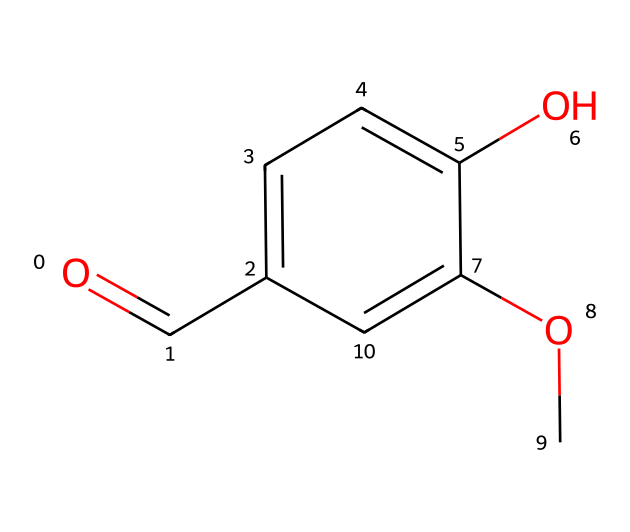What is the molecular formula of vanillin? To derive the molecular formula from the SMILES representation, count the carbon (C), hydrogen (H), and oxygen (O) atoms. The structure has 8 carbons, 8 hydrogens, and 3 oxygens, leading to a formula of C8H8O3.
Answer: C8H8O3 How many hydroxyl (–OH) groups are present in vanillin? Looking at the SMILES structure, the presence of an –OH group is indicated by the "O" connected to a carbon "c". There is one such –OH group in the structure.
Answer: 1 What functional groups are present in vanillin? Analyzing the structure, vanillin features a hydroxyl group (–OH) and an aldehyde group (–CHO) due to the presence of the carbonyl oxygen (=O) next to a carbon atom.
Answer: hydroxyl, aldehyde Is vanillin aromatic? The presence of an aromatic ring is evident from the "c" notations in the SMILES, indicating that carbon atoms are part of a cyclic, delocalized electron system. This confirms the aromatic nature of the compound.
Answer: yes What type of compound is vanillin classified as? Since vanillin contains a phenolic hydroxyl group and an aldehyde group, it fits the definition of a phenolic compound, specifically a phenolic aldehyde.
Answer: phenolic aldehyde How many double bonds are present in vanillin? Evaluating the structure, there is one double bond in the carbonyl group (=O) and three double bonds implicit in the aromatic ring connections, leading to a total of four.
Answer: 4 